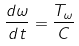<formula> <loc_0><loc_0><loc_500><loc_500>\frac { d \omega } { d t } = \frac { T _ { \omega } } { C }</formula> 